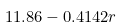<formula> <loc_0><loc_0><loc_500><loc_500>1 1 . 8 6 - 0 . 4 1 4 2 r</formula> 